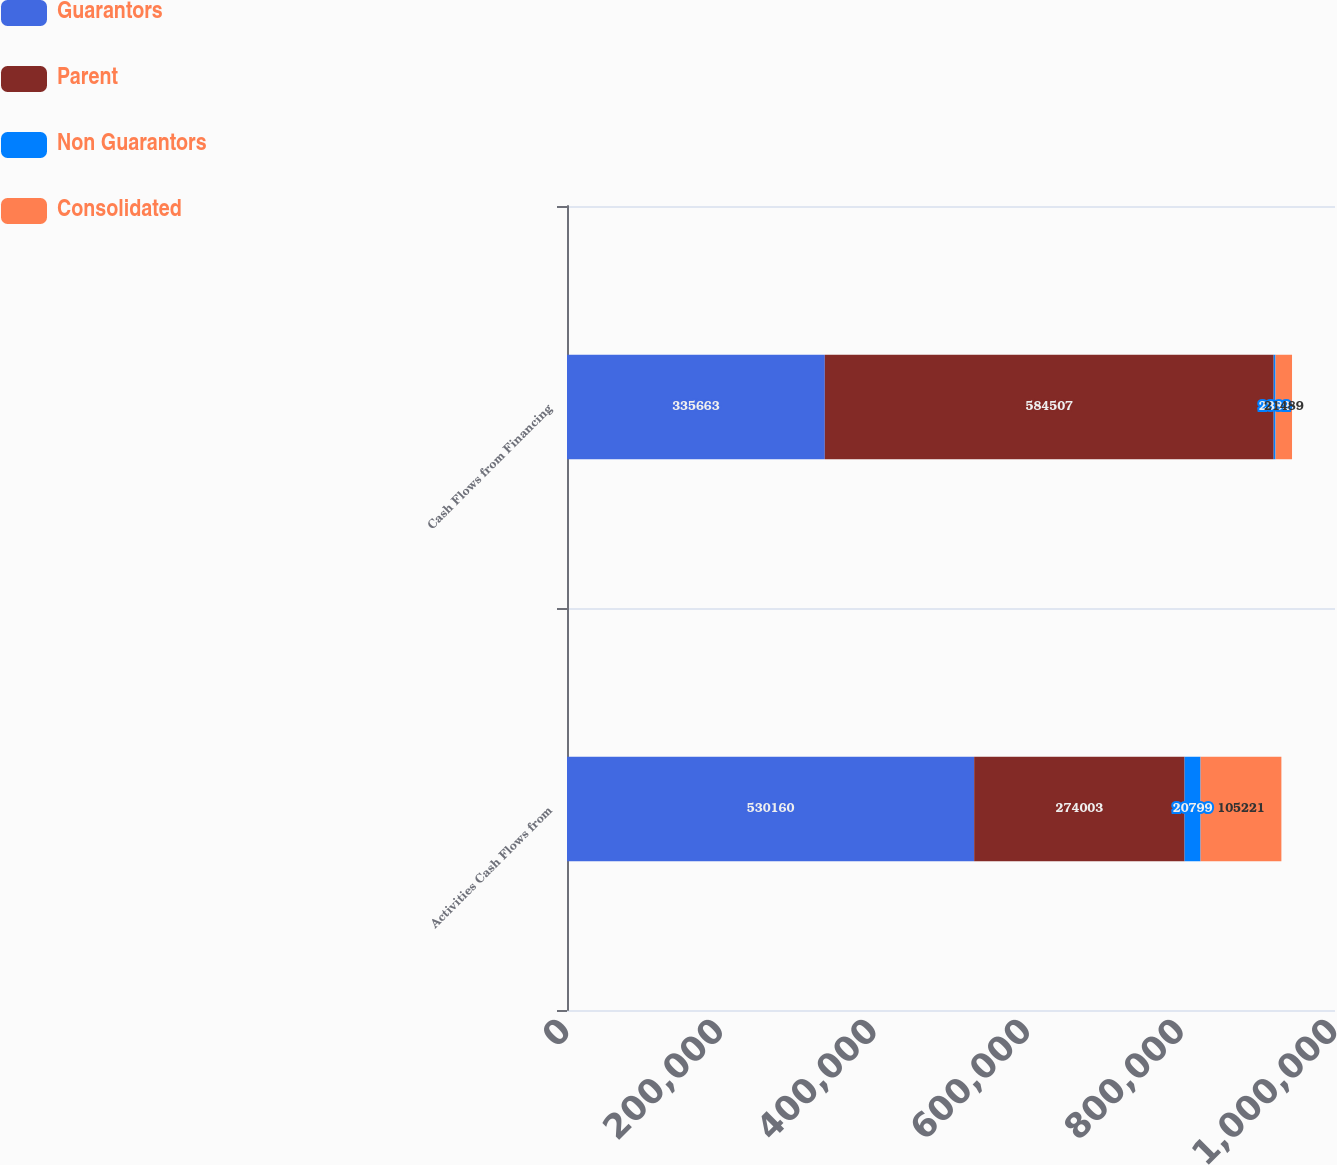Convert chart to OTSL. <chart><loc_0><loc_0><loc_500><loc_500><stacked_bar_chart><ecel><fcel>Activities Cash Flows from<fcel>Cash Flows from Financing<nl><fcel>Guarantors<fcel>530160<fcel>335663<nl><fcel>Parent<fcel>274003<fcel>584507<nl><fcel>Non Guarantors<fcel>20799<fcel>2382<nl><fcel>Consolidated<fcel>105221<fcel>21489<nl></chart> 